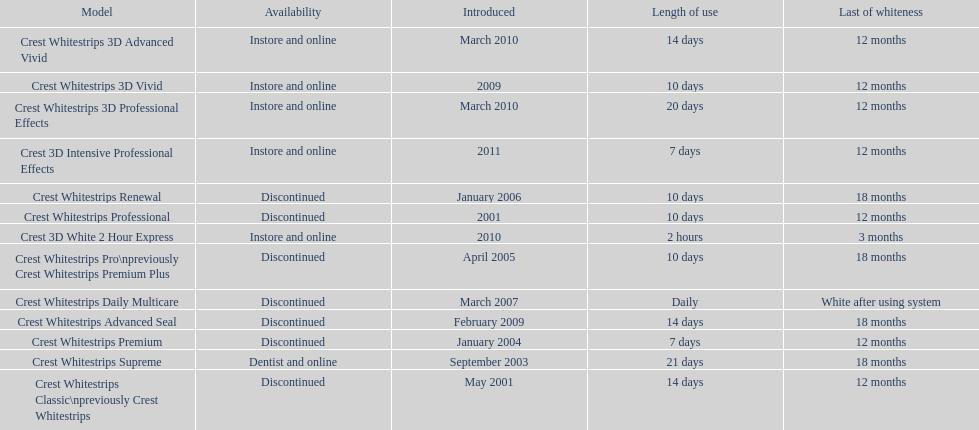Which discontinued product was introduced the same year as crest whitestrips 3d vivid? Crest Whitestrips Advanced Seal. 